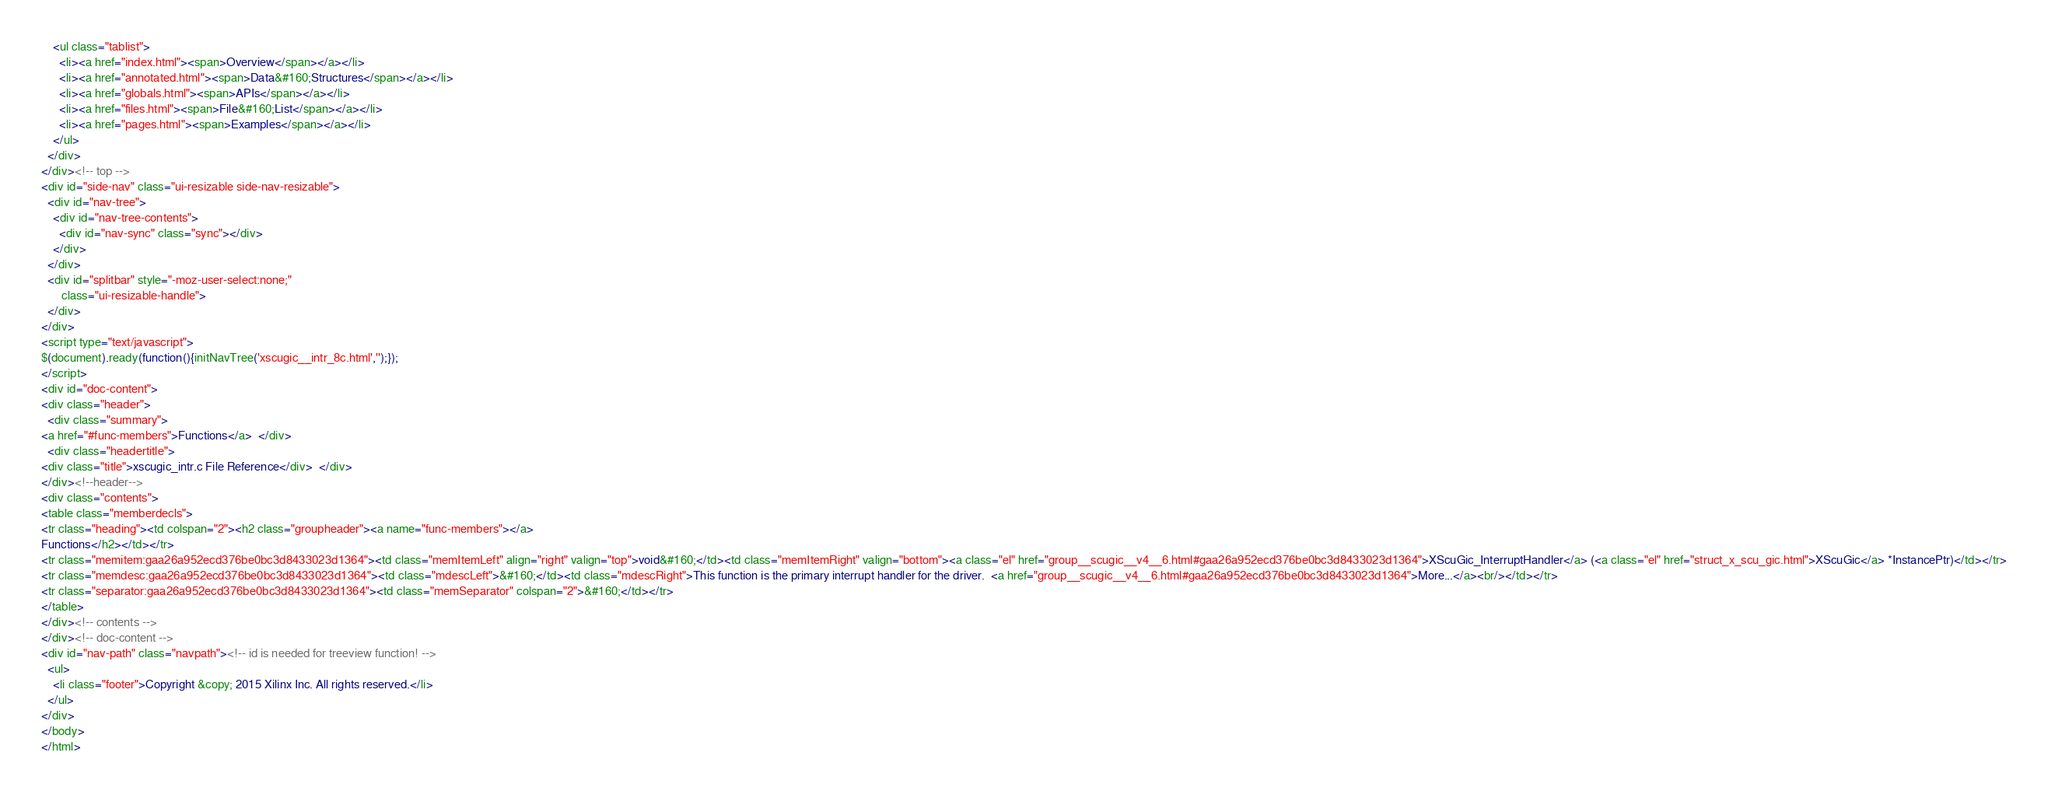Convert code to text. <code><loc_0><loc_0><loc_500><loc_500><_HTML_>    <ul class="tablist">
      <li><a href="index.html"><span>Overview</span></a></li>
      <li><a href="annotated.html"><span>Data&#160;Structures</span></a></li>
      <li><a href="globals.html"><span>APIs</span></a></li>
      <li><a href="files.html"><span>File&#160;List</span></a></li>
      <li><a href="pages.html"><span>Examples</span></a></li>
    </ul>
  </div>
</div><!-- top -->
<div id="side-nav" class="ui-resizable side-nav-resizable">
  <div id="nav-tree">
    <div id="nav-tree-contents">
      <div id="nav-sync" class="sync"></div>
    </div>
  </div>
  <div id="splitbar" style="-moz-user-select:none;" 
       class="ui-resizable-handle">
  </div>
</div>
<script type="text/javascript">
$(document).ready(function(){initNavTree('xscugic__intr_8c.html','');});
</script>
<div id="doc-content">
<div class="header">
  <div class="summary">
<a href="#func-members">Functions</a>  </div>
  <div class="headertitle">
<div class="title">xscugic_intr.c File Reference</div>  </div>
</div><!--header-->
<div class="contents">
<table class="memberdecls">
<tr class="heading"><td colspan="2"><h2 class="groupheader"><a name="func-members"></a>
Functions</h2></td></tr>
<tr class="memitem:gaa26a952ecd376be0bc3d8433023d1364"><td class="memItemLeft" align="right" valign="top">void&#160;</td><td class="memItemRight" valign="bottom"><a class="el" href="group__scugic__v4__6.html#gaa26a952ecd376be0bc3d8433023d1364">XScuGic_InterruptHandler</a> (<a class="el" href="struct_x_scu_gic.html">XScuGic</a> *InstancePtr)</td></tr>
<tr class="memdesc:gaa26a952ecd376be0bc3d8433023d1364"><td class="mdescLeft">&#160;</td><td class="mdescRight">This function is the primary interrupt handler for the driver.  <a href="group__scugic__v4__6.html#gaa26a952ecd376be0bc3d8433023d1364">More...</a><br/></td></tr>
<tr class="separator:gaa26a952ecd376be0bc3d8433023d1364"><td class="memSeparator" colspan="2">&#160;</td></tr>
</table>
</div><!-- contents -->
</div><!-- doc-content -->
<div id="nav-path" class="navpath"><!-- id is needed for treeview function! -->
  <ul>
    <li class="footer">Copyright &copy; 2015 Xilinx Inc. All rights reserved.</li>
  </ul>
</div>
</body>
</html>
</code> 